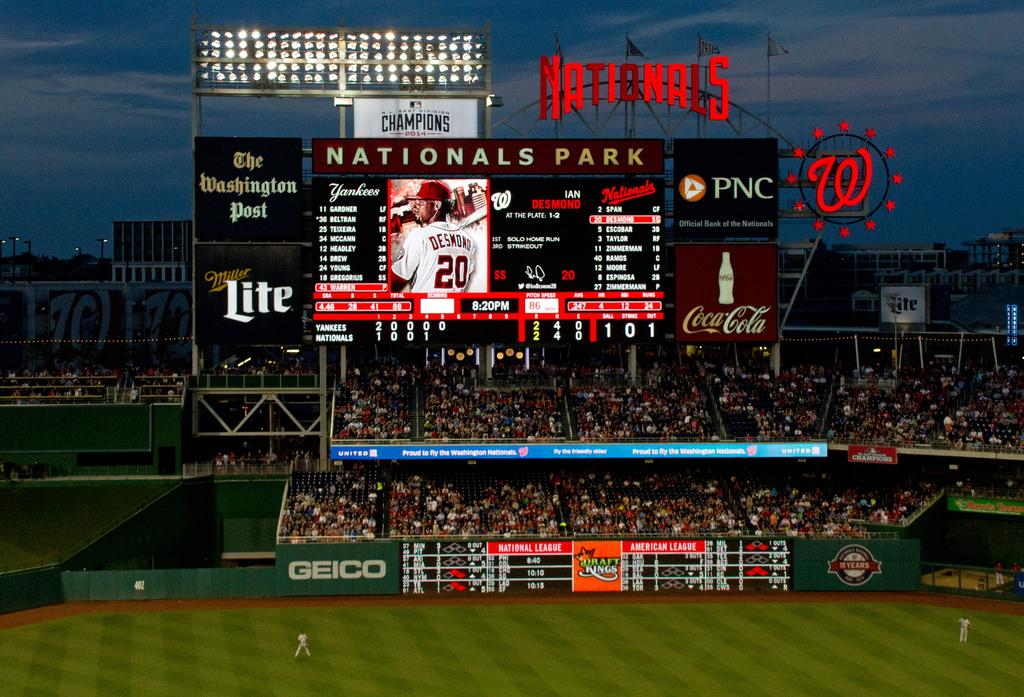Provide a one-sentence caption for the provided image. Large audience of people watching a baseball game at Nationals Park. 